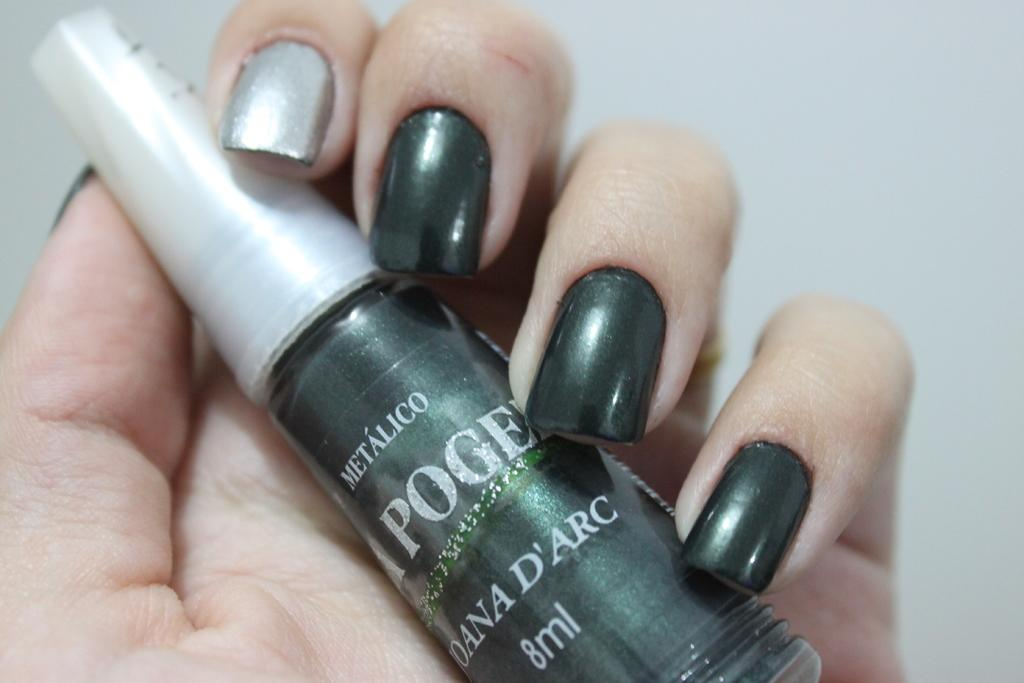<image>
Present a compact description of the photo's key features. a persons nails are painted with Metalico nail polish 